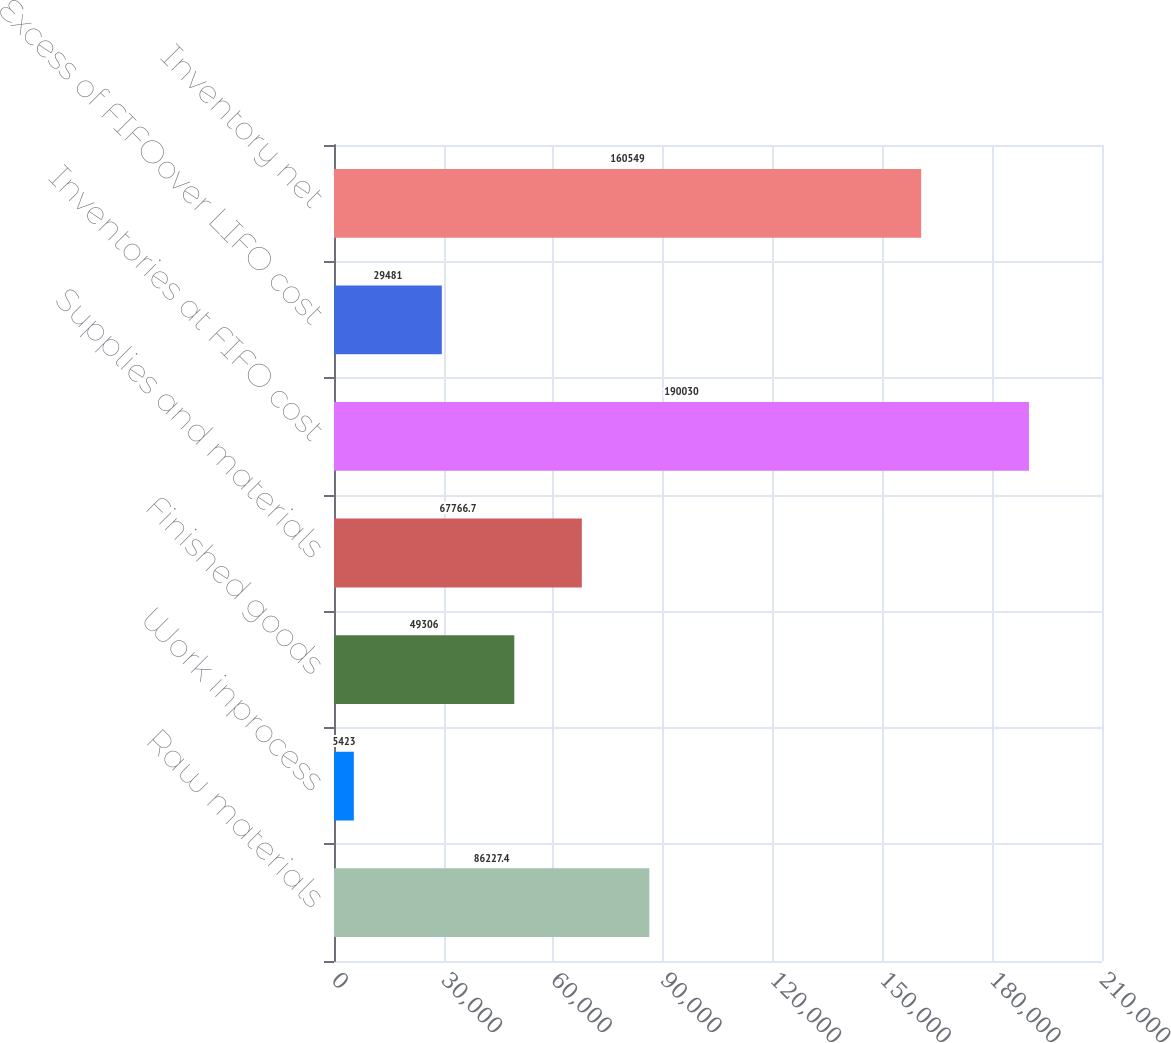Convert chart to OTSL. <chart><loc_0><loc_0><loc_500><loc_500><bar_chart><fcel>Raw materials<fcel>Work inprocess<fcel>Finished goods<fcel>Supplies and materials<fcel>Inventories at FIFO cost<fcel>Excess of FIFOover LIFO cost<fcel>Inventory net<nl><fcel>86227.4<fcel>5423<fcel>49306<fcel>67766.7<fcel>190030<fcel>29481<fcel>160549<nl></chart> 